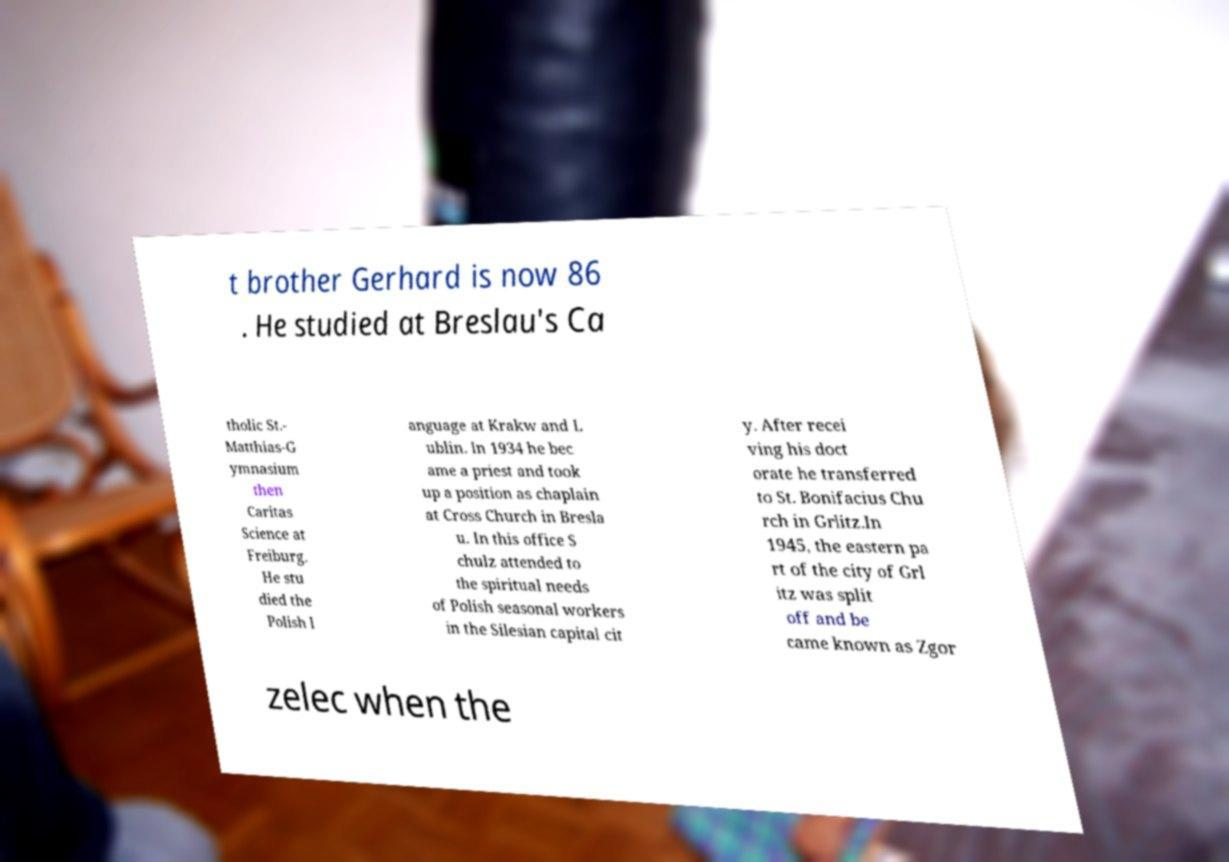Could you assist in decoding the text presented in this image and type it out clearly? t brother Gerhard is now 86 . He studied at Breslau's Ca tholic St.- Matthias-G ymnasium then Caritas Science at Freiburg. He stu died the Polish l anguage at Krakw and L ublin. In 1934 he bec ame a priest and took up a position as chaplain at Cross Church in Bresla u. In this office S chulz attended to the spiritual needs of Polish seasonal workers in the Silesian capital cit y. After recei ving his doct orate he transferred to St. Bonifacius Chu rch in Grlitz.In 1945, the eastern pa rt of the city of Grl itz was split off and be came known as Zgor zelec when the 